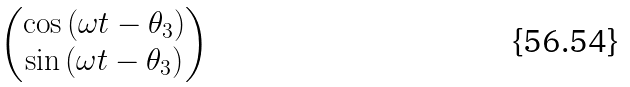Convert formula to latex. <formula><loc_0><loc_0><loc_500><loc_500>\begin{pmatrix} \cos { ( \omega t - \theta _ { 3 } ) } \\ \sin { ( \omega t - \theta _ { 3 } ) } \end{pmatrix}</formula> 